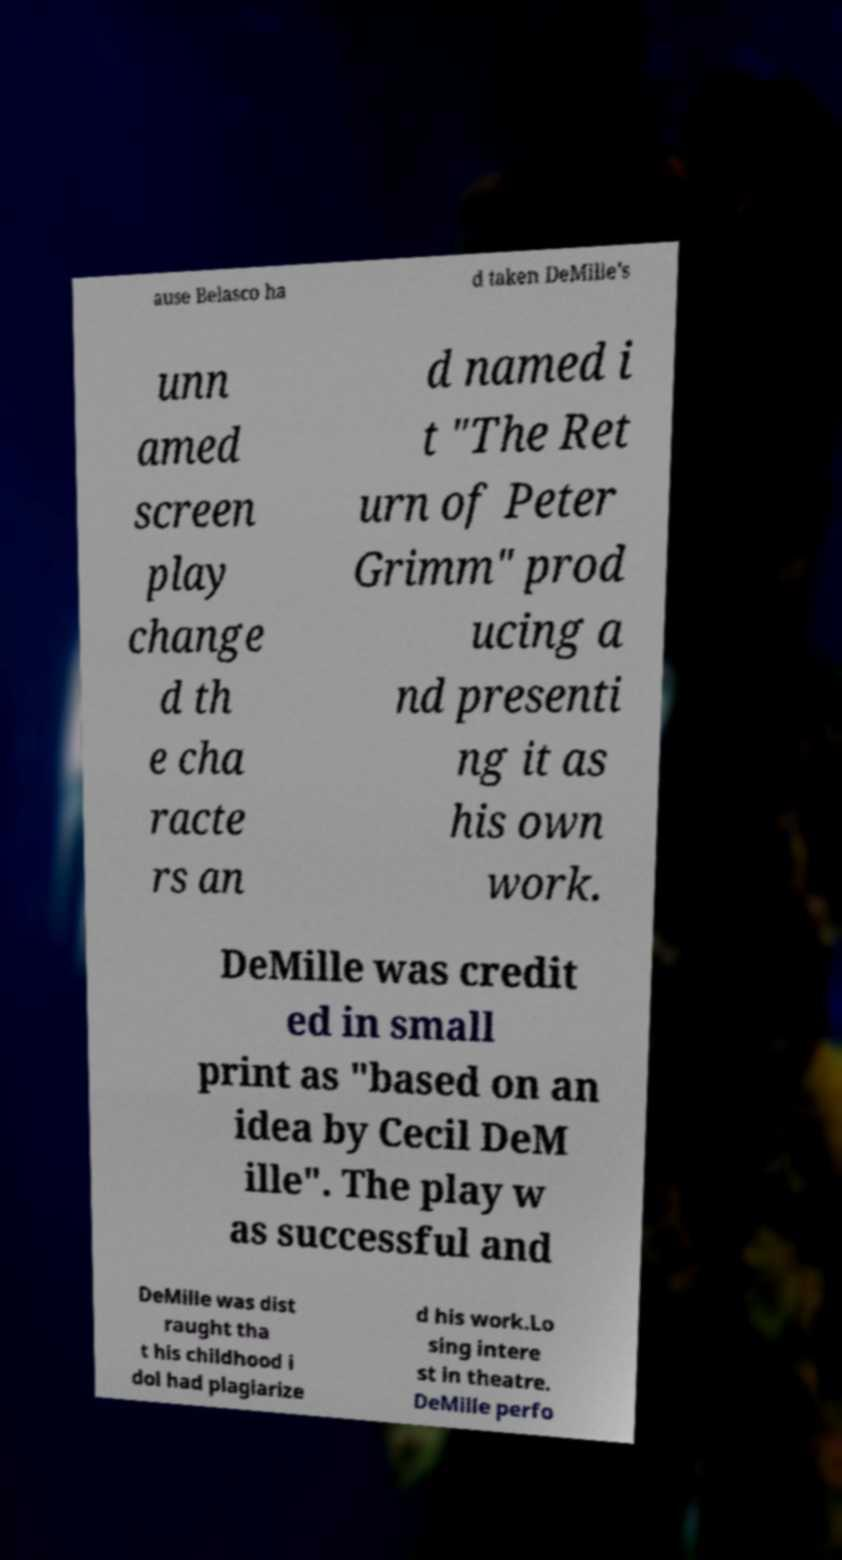Please read and relay the text visible in this image. What does it say? ause Belasco ha d taken DeMille's unn amed screen play change d th e cha racte rs an d named i t "The Ret urn of Peter Grimm" prod ucing a nd presenti ng it as his own work. DeMille was credit ed in small print as "based on an idea by Cecil DeM ille". The play w as successful and DeMille was dist raught tha t his childhood i dol had plagiarize d his work.Lo sing intere st in theatre. DeMille perfo 